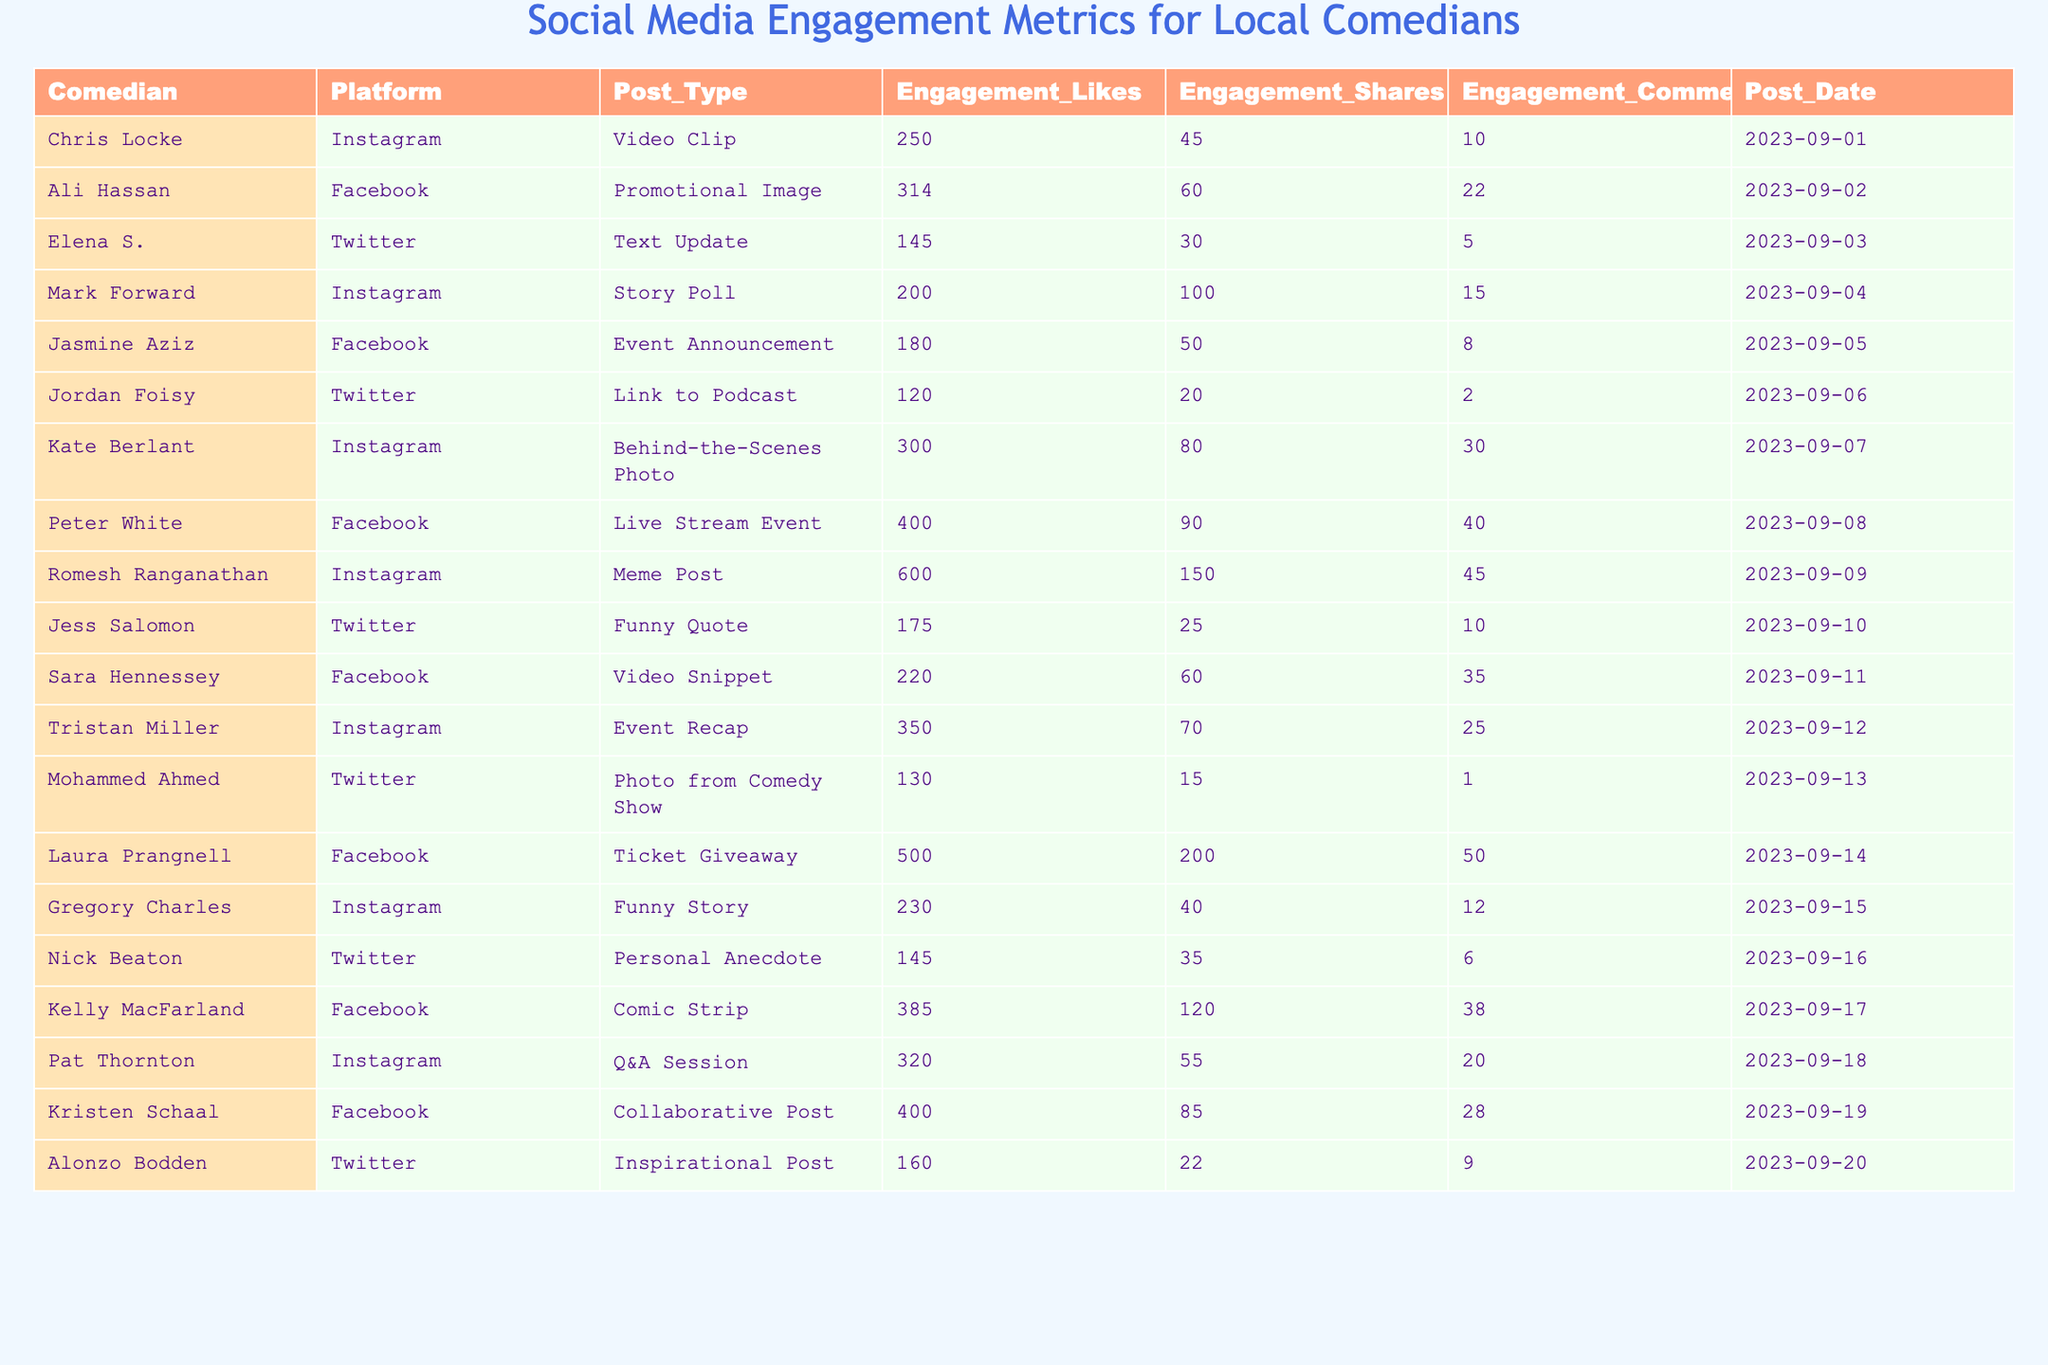What is the post date of Romesh Ranganathan's meme post? The table shows Romesh Ranganathan's meme post listed under the "Post_Date" column. The date is "2023-09-09".
Answer: 2023-09-09 Which comedian received the highest number of engagement likes? By checking the "Engagement_Likes" column, the highest value is 600 for Romesh Ranganathan's meme post.
Answer: Romesh Ranganathan What is the total number of engagement shares across all posts from Facebook? From the "Engagement_Shares" column, we sum the Facebook entries: 60 + 50 + 90 + 200 + 120 + 85 = 605.
Answer: 605 How many comments did the post from Laura Prangnell receive? Laura Prangnell's post has a value of 50 under the "Engagement_Comments" column.
Answer: 50 Which platform had the most posts in the table? Counting the number of occurrences for each platform, Instagram has 8, Facebook has 7, and Twitter has 6. So, Instagram has the most.
Answer: Instagram What is the average number of engagement comments for Twitter posts? There are 6 Twitter posts with comments: 5, 2, 1, 10, 6, 9. The sum is 33, divided by 6 gives an average of 5.5.
Answer: 5.5 Is it true that Peter White's post had more engagement likes than Kelly MacFarland's? Comparing their engagement likes: Peter White has 400 while Kelly MacFarland has 385. Since 400 > 385, the statement is true.
Answer: Yes Which comedian had the second-highest engagement shares, and how many did they receive? Checking the "Engagement_Shares" column, Romesh Ranganathan leads with 150, and Laura Prangnell follows with 200. Thus, Laura Prangnell had the second-highest shares with 200.
Answer: Laura Prangnell, 200 What is the total number of engagement likes for Instagram posts? The Instagram engagement likes are: 250, 200, 300, 600, 350, and 320. Adding them gives 2020.
Answer: 2020 Among the Facebook posts, which one had the least engagement shares? The shares for Facebook posts are: 60, 50, 90, 200, 120, 85. The least is 50 from Jasmine Aziz's event announcement.
Answer: 50 